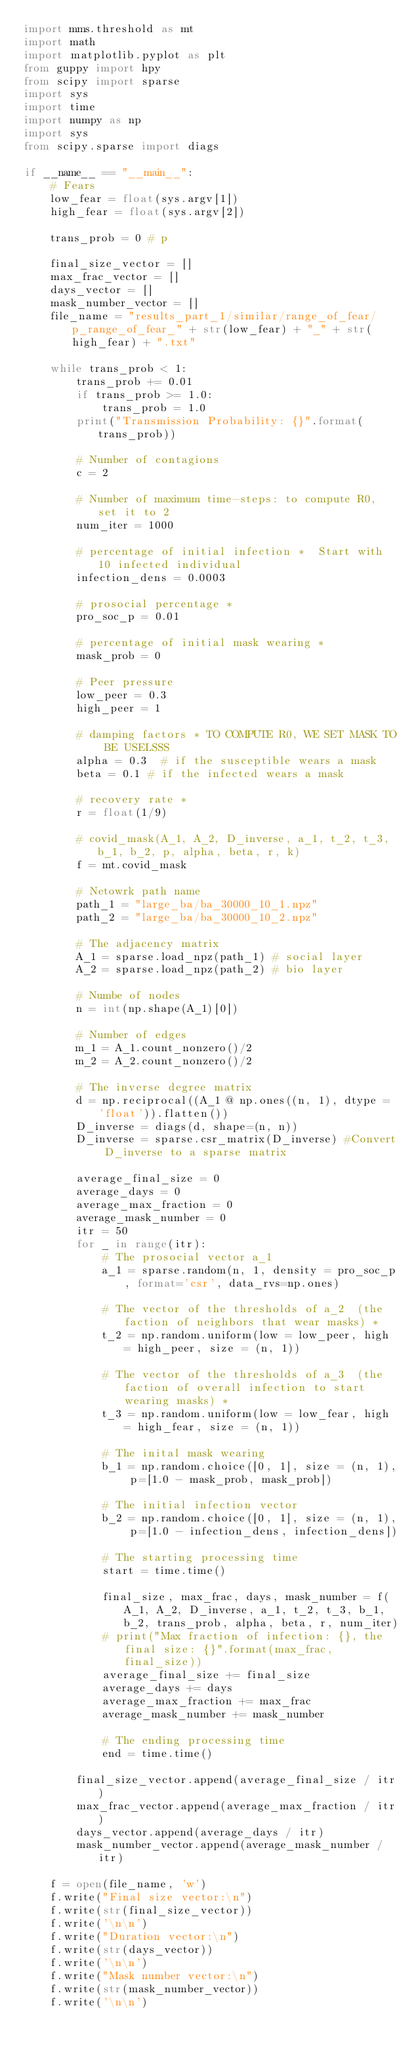<code> <loc_0><loc_0><loc_500><loc_500><_Python_>import mms.threshold as mt
import math
import matplotlib.pyplot as plt
from guppy import hpy
from scipy import sparse
import sys
import time
import numpy as np
import sys
from scipy.sparse import diags

if __name__ == "__main__":
    # Fears
    low_fear = float(sys.argv[1])
    high_fear = float(sys.argv[2])

    trans_prob = 0 # p

    final_size_vector = []
    max_frac_vector = []
    days_vector = []
    mask_number_vector = []
    file_name = "results_part_1/similar/range_of_fear/p_range_of_fear_" + str(low_fear) + "_" + str(high_fear) + ".txt"

    while trans_prob < 1:
        trans_prob += 0.01
        if trans_prob >= 1.0:
            trans_prob = 1.0
        print("Transmission Probability: {}".format(trans_prob))
    
        # Number of contagions
        c = 2

        # Number of maximum time-steps: to compute R0, set it to 2
        num_iter = 1000

        # percentage of initial infection *  Start with 10 infected individual
        infection_dens = 0.0003

        # prosocial percentage * 
        pro_soc_p = 0.01

        # percentage of initial mask wearing * 
        mask_prob = 0

        # Peer pressure
        low_peer = 0.3
        high_peer = 1
 
        # damping factors * TO COMPUTE R0, WE SET MASK TO BE USELSSS
        alpha = 0.3  # if the susceptible wears a mask
        beta = 0.1 # if the infected wears a mask

        # recovery rate * 
        r = float(1/9)

        # covid_mask(A_1, A_2, D_inverse, a_1, t_2, t_3, b_1, b_2, p, alpha, beta, r, k)
        f = mt.covid_mask
    
        # Netowrk path name
        path_1 = "large_ba/ba_30000_10_1.npz"
        path_2 = "large_ba/ba_30000_10_2.npz"

        # The adjacency matrix
        A_1 = sparse.load_npz(path_1) # social layer
        A_2 = sparse.load_npz(path_2) # bio layer

        # Numbe of nodes
        n = int(np.shape(A_1)[0]) 

        # Number of edges
        m_1 = A_1.count_nonzero()/2
        m_2 = A_2.count_nonzero()/2

        # The inverse degree matrix
        d = np.reciprocal((A_1 @ np.ones((n, 1), dtype = 'float')).flatten())
        D_inverse = diags(d, shape=(n, n))
        D_inverse = sparse.csr_matrix(D_inverse) #Convert D_inverse to a sparse matrix
    
        average_final_size = 0
        average_days = 0
        average_max_fraction = 0
        average_mask_number = 0
        itr = 50
        for _ in range(itr):
            # The prosocial vector a_1
            a_1 = sparse.random(n, 1, density = pro_soc_p, format='csr', data_rvs=np.ones)

            # The vector of the thresholds of a_2  (the faction of neighbors that wear masks) *
            t_2 = np.random.uniform(low = low_peer, high = high_peer, size = (n, 1))

            # The vector of the thresholds of a_3  (the faction of overall infection to start wearing masks) *
            t_3 = np.random.uniform(low = low_fear, high = high_fear, size = (n, 1))

            # The inital mask wearing
            b_1 = np.random.choice([0, 1], size = (n, 1), p=[1.0 - mask_prob, mask_prob])

            # The initial infection vector
            b_2 = np.random.choice([0, 1], size = (n, 1), p=[1.0 - infection_dens, infection_dens])
        
            # The starting processing time
            start = time.time()
            
            final_size, max_frac, days, mask_number = f(A_1, A_2, D_inverse, a_1, t_2, t_3, b_1, b_2, trans_prob, alpha, beta, r, num_iter)
            # print("Max fraction of infection: {}, the final size: {}".format(max_frac, final_size))
            average_final_size += final_size
            average_days += days
            average_max_fraction += max_frac
            average_mask_number += mask_number

            # The ending processing time
            end = time.time()

        final_size_vector.append(average_final_size / itr)
        max_frac_vector.append(average_max_fraction / itr)
        days_vector.append(average_days / itr)
        mask_number_vector.append(average_mask_number / itr)
   
    f = open(file_name, 'w')
    f.write("Final size vector:\n")
    f.write(str(final_size_vector))
    f.write('\n\n')
    f.write("Duration vector:\n")
    f.write(str(days_vector))
    f.write('\n\n')
    f.write("Mask number vector:\n")
    f.write(str(mask_number_vector))
    f.write('\n\n')
</code> 